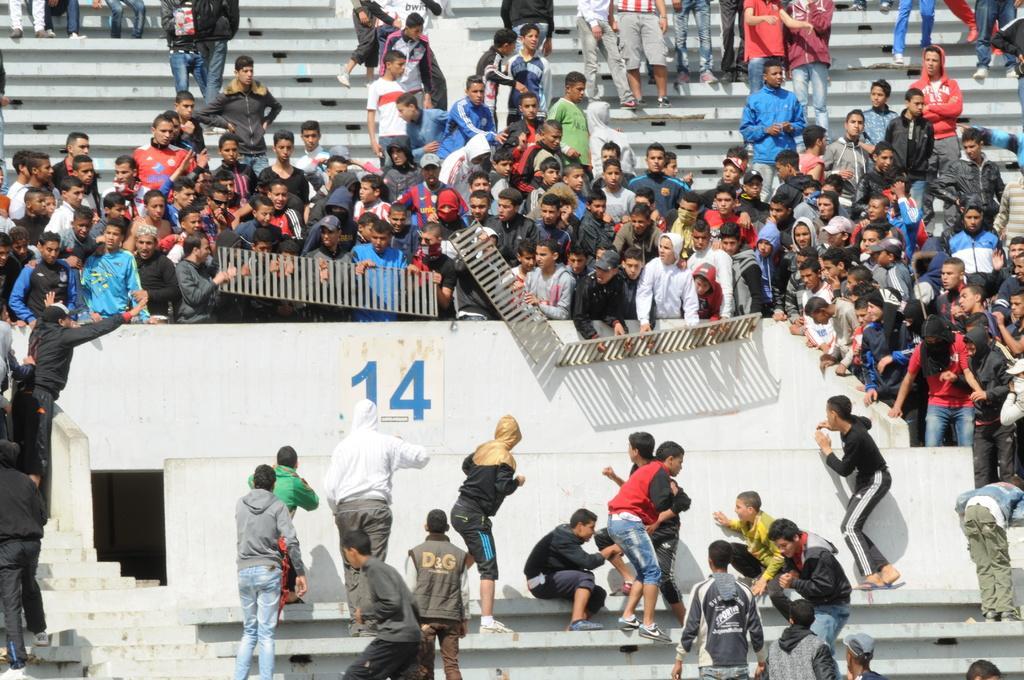In one or two sentences, can you explain what this image depicts? This image consists of many people. It looks like they are fighting. At the bottom, there are steps. 